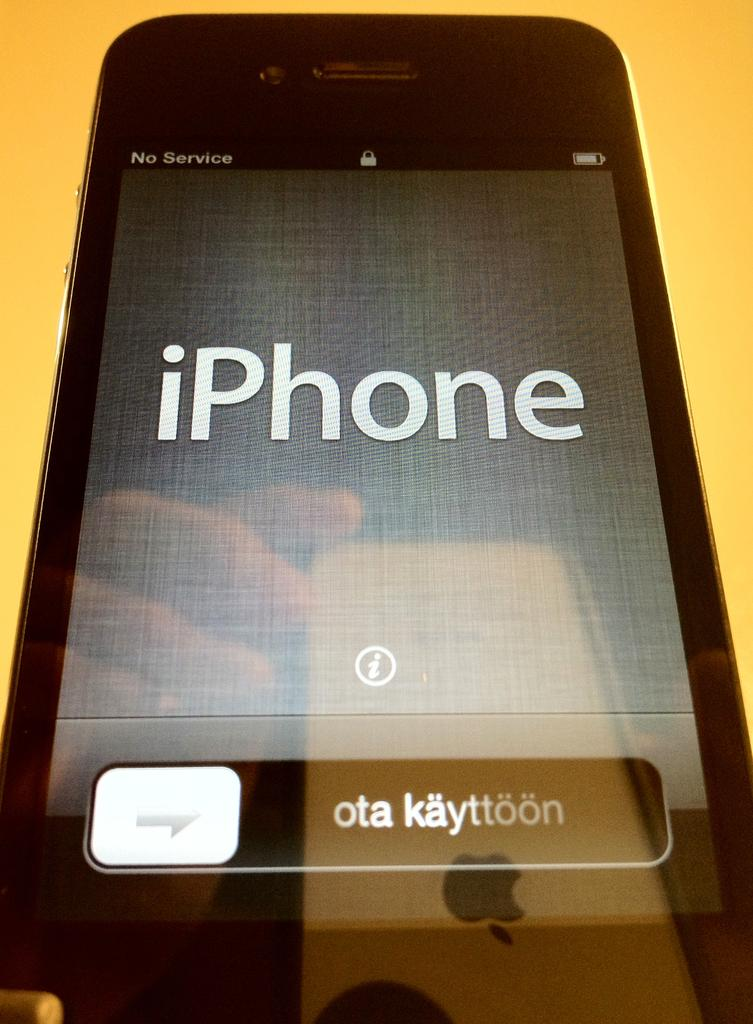<image>
Create a compact narrative representing the image presented. An iPhone with no service has a reflection in it's screen of a hand holding another iPhone. 